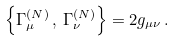<formula> <loc_0><loc_0><loc_500><loc_500>\left \{ \Gamma ^ { ( N ) } _ { \mu } \, , \, \Gamma ^ { ( N ) } _ { \nu } \right \} = 2 g _ { \mu \nu } \, .</formula> 